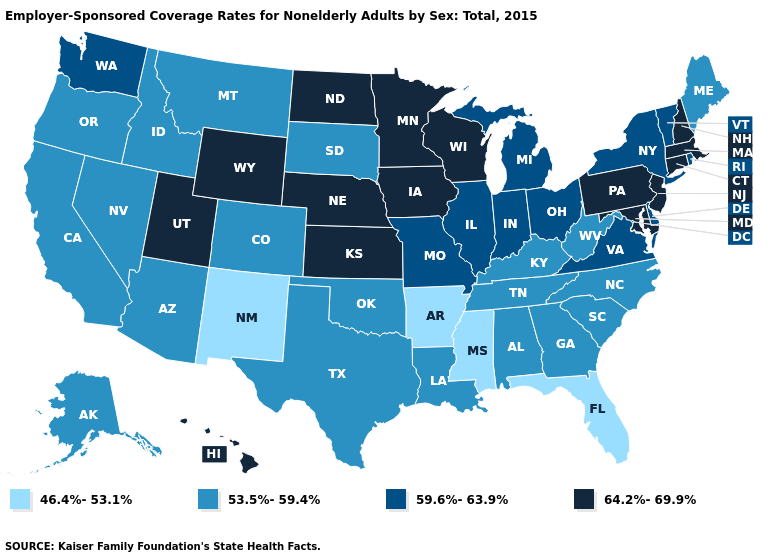Does Nevada have the same value as Massachusetts?
Answer briefly. No. What is the value of Montana?
Short answer required. 53.5%-59.4%. Name the states that have a value in the range 64.2%-69.9%?
Give a very brief answer. Connecticut, Hawaii, Iowa, Kansas, Maryland, Massachusetts, Minnesota, Nebraska, New Hampshire, New Jersey, North Dakota, Pennsylvania, Utah, Wisconsin, Wyoming. Name the states that have a value in the range 46.4%-53.1%?
Give a very brief answer. Arkansas, Florida, Mississippi, New Mexico. Name the states that have a value in the range 64.2%-69.9%?
Short answer required. Connecticut, Hawaii, Iowa, Kansas, Maryland, Massachusetts, Minnesota, Nebraska, New Hampshire, New Jersey, North Dakota, Pennsylvania, Utah, Wisconsin, Wyoming. What is the value of North Carolina?
Concise answer only. 53.5%-59.4%. Does Oregon have the lowest value in the USA?
Concise answer only. No. What is the lowest value in the USA?
Short answer required. 46.4%-53.1%. Among the states that border Tennessee , which have the lowest value?
Write a very short answer. Arkansas, Mississippi. Does Minnesota have the same value as Mississippi?
Answer briefly. No. Does New Hampshire have the highest value in the USA?
Concise answer only. Yes. Does the first symbol in the legend represent the smallest category?
Write a very short answer. Yes. Does Wisconsin have the highest value in the USA?
Keep it brief. Yes. Name the states that have a value in the range 59.6%-63.9%?
Answer briefly. Delaware, Illinois, Indiana, Michigan, Missouri, New York, Ohio, Rhode Island, Vermont, Virginia, Washington. Which states hav the highest value in the South?
Write a very short answer. Maryland. 